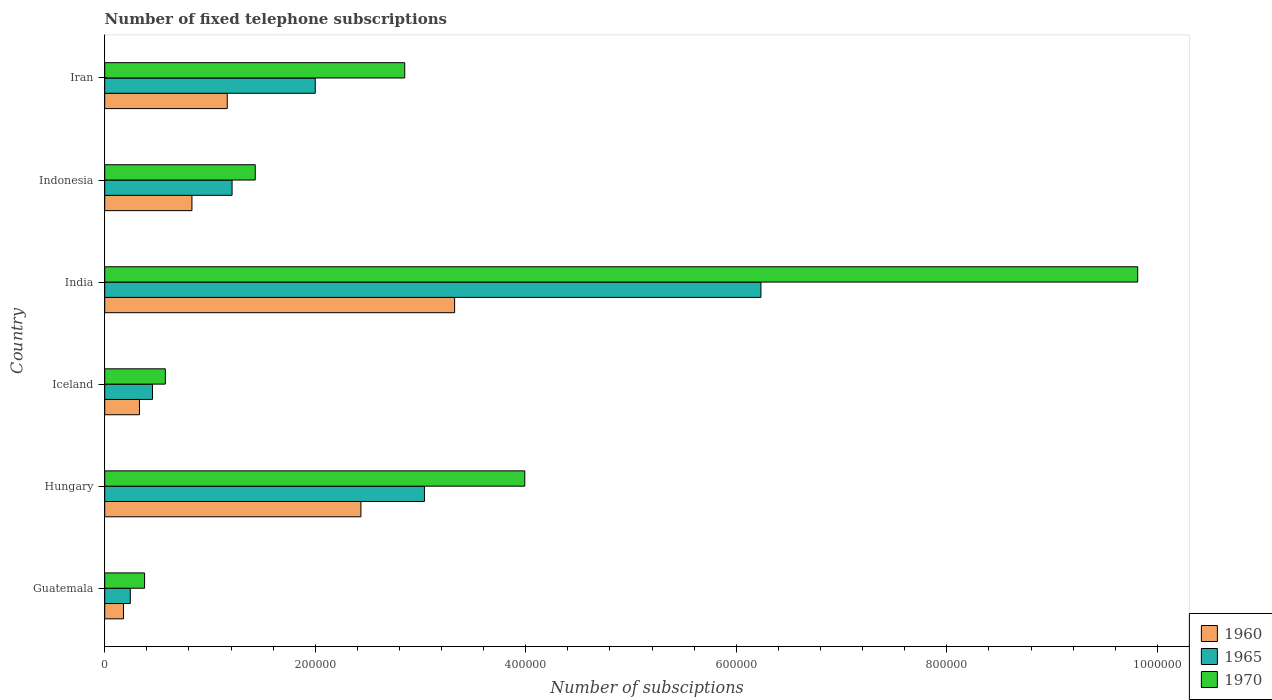How many bars are there on the 2nd tick from the top?
Provide a short and direct response. 3. How many bars are there on the 6th tick from the bottom?
Give a very brief answer. 3. What is the label of the 5th group of bars from the top?
Offer a terse response. Hungary. In how many cases, is the number of bars for a given country not equal to the number of legend labels?
Your answer should be compact. 0. What is the number of fixed telephone subscriptions in 1970 in Iceland?
Provide a succinct answer. 5.76e+04. Across all countries, what is the maximum number of fixed telephone subscriptions in 1965?
Provide a short and direct response. 6.23e+05. Across all countries, what is the minimum number of fixed telephone subscriptions in 1970?
Provide a succinct answer. 3.79e+04. In which country was the number of fixed telephone subscriptions in 1965 maximum?
Give a very brief answer. India. In which country was the number of fixed telephone subscriptions in 1965 minimum?
Provide a succinct answer. Guatemala. What is the total number of fixed telephone subscriptions in 1965 in the graph?
Your answer should be very brief. 1.32e+06. What is the difference between the number of fixed telephone subscriptions in 1960 in Guatemala and that in Hungary?
Your response must be concise. -2.26e+05. What is the difference between the number of fixed telephone subscriptions in 1965 in Iceland and the number of fixed telephone subscriptions in 1960 in Indonesia?
Your answer should be compact. -3.75e+04. What is the average number of fixed telephone subscriptions in 1960 per country?
Your answer should be compact. 1.38e+05. What is the difference between the number of fixed telephone subscriptions in 1970 and number of fixed telephone subscriptions in 1965 in Indonesia?
Your answer should be compact. 2.20e+04. What is the ratio of the number of fixed telephone subscriptions in 1960 in Hungary to that in Iran?
Offer a very short reply. 2.09. What is the difference between the highest and the second highest number of fixed telephone subscriptions in 1960?
Your answer should be compact. 8.90e+04. What is the difference between the highest and the lowest number of fixed telephone subscriptions in 1960?
Make the answer very short. 3.15e+05. In how many countries, is the number of fixed telephone subscriptions in 1965 greater than the average number of fixed telephone subscriptions in 1965 taken over all countries?
Offer a terse response. 2. What does the 1st bar from the bottom in Iran represents?
Your answer should be very brief. 1960. How many bars are there?
Ensure brevity in your answer.  18. Are all the bars in the graph horizontal?
Provide a succinct answer. Yes. Does the graph contain any zero values?
Give a very brief answer. No. Where does the legend appear in the graph?
Make the answer very short. Bottom right. What is the title of the graph?
Your answer should be very brief. Number of fixed telephone subscriptions. Does "1988" appear as one of the legend labels in the graph?
Offer a very short reply. No. What is the label or title of the X-axis?
Keep it short and to the point. Number of subsciptions. What is the label or title of the Y-axis?
Your answer should be very brief. Country. What is the Number of subsciptions in 1960 in Guatemala?
Keep it short and to the point. 1.78e+04. What is the Number of subsciptions of 1965 in Guatemala?
Your response must be concise. 2.43e+04. What is the Number of subsciptions in 1970 in Guatemala?
Provide a succinct answer. 3.79e+04. What is the Number of subsciptions in 1960 in Hungary?
Keep it short and to the point. 2.43e+05. What is the Number of subsciptions in 1965 in Hungary?
Offer a very short reply. 3.04e+05. What is the Number of subsciptions of 1970 in Hungary?
Your answer should be compact. 3.99e+05. What is the Number of subsciptions in 1960 in Iceland?
Keep it short and to the point. 3.30e+04. What is the Number of subsciptions of 1965 in Iceland?
Offer a terse response. 4.54e+04. What is the Number of subsciptions in 1970 in Iceland?
Make the answer very short. 5.76e+04. What is the Number of subsciptions in 1960 in India?
Your answer should be compact. 3.32e+05. What is the Number of subsciptions in 1965 in India?
Your response must be concise. 6.23e+05. What is the Number of subsciptions in 1970 in India?
Offer a terse response. 9.81e+05. What is the Number of subsciptions in 1960 in Indonesia?
Ensure brevity in your answer.  8.29e+04. What is the Number of subsciptions of 1965 in Indonesia?
Your answer should be very brief. 1.21e+05. What is the Number of subsciptions in 1970 in Indonesia?
Keep it short and to the point. 1.43e+05. What is the Number of subsciptions in 1960 in Iran?
Offer a very short reply. 1.16e+05. What is the Number of subsciptions in 1970 in Iran?
Ensure brevity in your answer.  2.85e+05. Across all countries, what is the maximum Number of subsciptions in 1960?
Your answer should be compact. 3.32e+05. Across all countries, what is the maximum Number of subsciptions in 1965?
Provide a succinct answer. 6.23e+05. Across all countries, what is the maximum Number of subsciptions in 1970?
Give a very brief answer. 9.81e+05. Across all countries, what is the minimum Number of subsciptions of 1960?
Your response must be concise. 1.78e+04. Across all countries, what is the minimum Number of subsciptions of 1965?
Your answer should be compact. 2.43e+04. Across all countries, what is the minimum Number of subsciptions of 1970?
Your answer should be compact. 3.79e+04. What is the total Number of subsciptions in 1960 in the graph?
Provide a short and direct response. 8.26e+05. What is the total Number of subsciptions of 1965 in the graph?
Offer a terse response. 1.32e+06. What is the total Number of subsciptions of 1970 in the graph?
Your response must be concise. 1.90e+06. What is the difference between the Number of subsciptions in 1960 in Guatemala and that in Hungary?
Your answer should be compact. -2.26e+05. What is the difference between the Number of subsciptions in 1965 in Guatemala and that in Hungary?
Ensure brevity in your answer.  -2.79e+05. What is the difference between the Number of subsciptions in 1970 in Guatemala and that in Hungary?
Provide a succinct answer. -3.61e+05. What is the difference between the Number of subsciptions in 1960 in Guatemala and that in Iceland?
Your response must be concise. -1.52e+04. What is the difference between the Number of subsciptions in 1965 in Guatemala and that in Iceland?
Provide a short and direct response. -2.11e+04. What is the difference between the Number of subsciptions in 1970 in Guatemala and that in Iceland?
Offer a terse response. -1.97e+04. What is the difference between the Number of subsciptions of 1960 in Guatemala and that in India?
Give a very brief answer. -3.15e+05. What is the difference between the Number of subsciptions of 1965 in Guatemala and that in India?
Your response must be concise. -5.99e+05. What is the difference between the Number of subsciptions in 1970 in Guatemala and that in India?
Offer a very short reply. -9.43e+05. What is the difference between the Number of subsciptions in 1960 in Guatemala and that in Indonesia?
Your response must be concise. -6.50e+04. What is the difference between the Number of subsciptions of 1965 in Guatemala and that in Indonesia?
Offer a terse response. -9.67e+04. What is the difference between the Number of subsciptions in 1970 in Guatemala and that in Indonesia?
Make the answer very short. -1.05e+05. What is the difference between the Number of subsciptions of 1960 in Guatemala and that in Iran?
Offer a terse response. -9.86e+04. What is the difference between the Number of subsciptions in 1965 in Guatemala and that in Iran?
Provide a short and direct response. -1.76e+05. What is the difference between the Number of subsciptions of 1970 in Guatemala and that in Iran?
Your answer should be compact. -2.47e+05. What is the difference between the Number of subsciptions in 1960 in Hungary and that in Iceland?
Give a very brief answer. 2.10e+05. What is the difference between the Number of subsciptions in 1965 in Hungary and that in Iceland?
Keep it short and to the point. 2.58e+05. What is the difference between the Number of subsciptions in 1970 in Hungary and that in Iceland?
Give a very brief answer. 3.41e+05. What is the difference between the Number of subsciptions of 1960 in Hungary and that in India?
Ensure brevity in your answer.  -8.90e+04. What is the difference between the Number of subsciptions in 1965 in Hungary and that in India?
Ensure brevity in your answer.  -3.20e+05. What is the difference between the Number of subsciptions in 1970 in Hungary and that in India?
Make the answer very short. -5.82e+05. What is the difference between the Number of subsciptions in 1960 in Hungary and that in Indonesia?
Keep it short and to the point. 1.61e+05. What is the difference between the Number of subsciptions in 1965 in Hungary and that in Indonesia?
Your response must be concise. 1.83e+05. What is the difference between the Number of subsciptions in 1970 in Hungary and that in Indonesia?
Keep it short and to the point. 2.56e+05. What is the difference between the Number of subsciptions of 1960 in Hungary and that in Iran?
Provide a succinct answer. 1.27e+05. What is the difference between the Number of subsciptions in 1965 in Hungary and that in Iran?
Provide a succinct answer. 1.04e+05. What is the difference between the Number of subsciptions in 1970 in Hungary and that in Iran?
Make the answer very short. 1.14e+05. What is the difference between the Number of subsciptions in 1960 in Iceland and that in India?
Provide a succinct answer. -2.99e+05. What is the difference between the Number of subsciptions in 1965 in Iceland and that in India?
Your answer should be compact. -5.78e+05. What is the difference between the Number of subsciptions in 1970 in Iceland and that in India?
Provide a short and direct response. -9.24e+05. What is the difference between the Number of subsciptions of 1960 in Iceland and that in Indonesia?
Provide a succinct answer. -4.99e+04. What is the difference between the Number of subsciptions of 1965 in Iceland and that in Indonesia?
Provide a succinct answer. -7.56e+04. What is the difference between the Number of subsciptions in 1970 in Iceland and that in Indonesia?
Ensure brevity in your answer.  -8.54e+04. What is the difference between the Number of subsciptions in 1960 in Iceland and that in Iran?
Your answer should be very brief. -8.34e+04. What is the difference between the Number of subsciptions in 1965 in Iceland and that in Iran?
Your answer should be very brief. -1.55e+05. What is the difference between the Number of subsciptions of 1970 in Iceland and that in Iran?
Give a very brief answer. -2.27e+05. What is the difference between the Number of subsciptions of 1960 in India and that in Indonesia?
Give a very brief answer. 2.50e+05. What is the difference between the Number of subsciptions of 1965 in India and that in Indonesia?
Offer a terse response. 5.02e+05. What is the difference between the Number of subsciptions of 1970 in India and that in Indonesia?
Your response must be concise. 8.38e+05. What is the difference between the Number of subsciptions of 1960 in India and that in Iran?
Offer a very short reply. 2.16e+05. What is the difference between the Number of subsciptions in 1965 in India and that in Iran?
Your answer should be compact. 4.23e+05. What is the difference between the Number of subsciptions of 1970 in India and that in Iran?
Your response must be concise. 6.96e+05. What is the difference between the Number of subsciptions of 1960 in Indonesia and that in Iran?
Provide a succinct answer. -3.36e+04. What is the difference between the Number of subsciptions in 1965 in Indonesia and that in Iran?
Ensure brevity in your answer.  -7.90e+04. What is the difference between the Number of subsciptions of 1970 in Indonesia and that in Iran?
Make the answer very short. -1.42e+05. What is the difference between the Number of subsciptions of 1960 in Guatemala and the Number of subsciptions of 1965 in Hungary?
Provide a short and direct response. -2.86e+05. What is the difference between the Number of subsciptions in 1960 in Guatemala and the Number of subsciptions in 1970 in Hungary?
Your response must be concise. -3.81e+05. What is the difference between the Number of subsciptions in 1965 in Guatemala and the Number of subsciptions in 1970 in Hungary?
Your response must be concise. -3.75e+05. What is the difference between the Number of subsciptions in 1960 in Guatemala and the Number of subsciptions in 1965 in Iceland?
Make the answer very short. -2.75e+04. What is the difference between the Number of subsciptions of 1960 in Guatemala and the Number of subsciptions of 1970 in Iceland?
Offer a terse response. -3.98e+04. What is the difference between the Number of subsciptions of 1965 in Guatemala and the Number of subsciptions of 1970 in Iceland?
Make the answer very short. -3.33e+04. What is the difference between the Number of subsciptions of 1960 in Guatemala and the Number of subsciptions of 1965 in India?
Make the answer very short. -6.06e+05. What is the difference between the Number of subsciptions of 1960 in Guatemala and the Number of subsciptions of 1970 in India?
Ensure brevity in your answer.  -9.64e+05. What is the difference between the Number of subsciptions of 1965 in Guatemala and the Number of subsciptions of 1970 in India?
Offer a terse response. -9.57e+05. What is the difference between the Number of subsciptions in 1960 in Guatemala and the Number of subsciptions in 1965 in Indonesia?
Offer a terse response. -1.03e+05. What is the difference between the Number of subsciptions in 1960 in Guatemala and the Number of subsciptions in 1970 in Indonesia?
Make the answer very short. -1.25e+05. What is the difference between the Number of subsciptions in 1965 in Guatemala and the Number of subsciptions in 1970 in Indonesia?
Make the answer very short. -1.19e+05. What is the difference between the Number of subsciptions in 1960 in Guatemala and the Number of subsciptions in 1965 in Iran?
Provide a short and direct response. -1.82e+05. What is the difference between the Number of subsciptions in 1960 in Guatemala and the Number of subsciptions in 1970 in Iran?
Offer a very short reply. -2.67e+05. What is the difference between the Number of subsciptions of 1965 in Guatemala and the Number of subsciptions of 1970 in Iran?
Your response must be concise. -2.61e+05. What is the difference between the Number of subsciptions in 1960 in Hungary and the Number of subsciptions in 1965 in Iceland?
Your response must be concise. 1.98e+05. What is the difference between the Number of subsciptions in 1960 in Hungary and the Number of subsciptions in 1970 in Iceland?
Offer a very short reply. 1.86e+05. What is the difference between the Number of subsciptions in 1965 in Hungary and the Number of subsciptions in 1970 in Iceland?
Your answer should be very brief. 2.46e+05. What is the difference between the Number of subsciptions of 1960 in Hungary and the Number of subsciptions of 1965 in India?
Ensure brevity in your answer.  -3.80e+05. What is the difference between the Number of subsciptions of 1960 in Hungary and the Number of subsciptions of 1970 in India?
Offer a terse response. -7.38e+05. What is the difference between the Number of subsciptions in 1965 in Hungary and the Number of subsciptions in 1970 in India?
Make the answer very short. -6.78e+05. What is the difference between the Number of subsciptions of 1960 in Hungary and the Number of subsciptions of 1965 in Indonesia?
Make the answer very short. 1.22e+05. What is the difference between the Number of subsciptions of 1960 in Hungary and the Number of subsciptions of 1970 in Indonesia?
Offer a very short reply. 1.00e+05. What is the difference between the Number of subsciptions in 1965 in Hungary and the Number of subsciptions in 1970 in Indonesia?
Make the answer very short. 1.61e+05. What is the difference between the Number of subsciptions of 1960 in Hungary and the Number of subsciptions of 1965 in Iran?
Your response must be concise. 4.34e+04. What is the difference between the Number of subsciptions of 1960 in Hungary and the Number of subsciptions of 1970 in Iran?
Make the answer very short. -4.16e+04. What is the difference between the Number of subsciptions of 1965 in Hungary and the Number of subsciptions of 1970 in Iran?
Ensure brevity in your answer.  1.88e+04. What is the difference between the Number of subsciptions in 1960 in Iceland and the Number of subsciptions in 1965 in India?
Your answer should be compact. -5.90e+05. What is the difference between the Number of subsciptions of 1960 in Iceland and the Number of subsciptions of 1970 in India?
Keep it short and to the point. -9.48e+05. What is the difference between the Number of subsciptions of 1965 in Iceland and the Number of subsciptions of 1970 in India?
Offer a very short reply. -9.36e+05. What is the difference between the Number of subsciptions of 1960 in Iceland and the Number of subsciptions of 1965 in Indonesia?
Provide a short and direct response. -8.80e+04. What is the difference between the Number of subsciptions in 1960 in Iceland and the Number of subsciptions in 1970 in Indonesia?
Ensure brevity in your answer.  -1.10e+05. What is the difference between the Number of subsciptions in 1965 in Iceland and the Number of subsciptions in 1970 in Indonesia?
Provide a succinct answer. -9.76e+04. What is the difference between the Number of subsciptions of 1960 in Iceland and the Number of subsciptions of 1965 in Iran?
Offer a very short reply. -1.67e+05. What is the difference between the Number of subsciptions in 1960 in Iceland and the Number of subsciptions in 1970 in Iran?
Your answer should be compact. -2.52e+05. What is the difference between the Number of subsciptions of 1965 in Iceland and the Number of subsciptions of 1970 in Iran?
Ensure brevity in your answer.  -2.40e+05. What is the difference between the Number of subsciptions of 1960 in India and the Number of subsciptions of 1965 in Indonesia?
Make the answer very short. 2.11e+05. What is the difference between the Number of subsciptions in 1960 in India and the Number of subsciptions in 1970 in Indonesia?
Offer a very short reply. 1.89e+05. What is the difference between the Number of subsciptions in 1965 in India and the Number of subsciptions in 1970 in Indonesia?
Your answer should be compact. 4.80e+05. What is the difference between the Number of subsciptions of 1960 in India and the Number of subsciptions of 1965 in Iran?
Ensure brevity in your answer.  1.32e+05. What is the difference between the Number of subsciptions in 1960 in India and the Number of subsciptions in 1970 in Iran?
Your response must be concise. 4.74e+04. What is the difference between the Number of subsciptions of 1965 in India and the Number of subsciptions of 1970 in Iran?
Ensure brevity in your answer.  3.38e+05. What is the difference between the Number of subsciptions in 1960 in Indonesia and the Number of subsciptions in 1965 in Iran?
Provide a short and direct response. -1.17e+05. What is the difference between the Number of subsciptions of 1960 in Indonesia and the Number of subsciptions of 1970 in Iran?
Provide a succinct answer. -2.02e+05. What is the difference between the Number of subsciptions in 1965 in Indonesia and the Number of subsciptions in 1970 in Iran?
Keep it short and to the point. -1.64e+05. What is the average Number of subsciptions of 1960 per country?
Make the answer very short. 1.38e+05. What is the average Number of subsciptions in 1965 per country?
Your response must be concise. 2.20e+05. What is the average Number of subsciptions in 1970 per country?
Ensure brevity in your answer.  3.17e+05. What is the difference between the Number of subsciptions in 1960 and Number of subsciptions in 1965 in Guatemala?
Make the answer very short. -6485. What is the difference between the Number of subsciptions in 1960 and Number of subsciptions in 1970 in Guatemala?
Your answer should be very brief. -2.00e+04. What is the difference between the Number of subsciptions in 1965 and Number of subsciptions in 1970 in Guatemala?
Ensure brevity in your answer.  -1.36e+04. What is the difference between the Number of subsciptions of 1960 and Number of subsciptions of 1965 in Hungary?
Ensure brevity in your answer.  -6.04e+04. What is the difference between the Number of subsciptions of 1960 and Number of subsciptions of 1970 in Hungary?
Make the answer very short. -1.56e+05. What is the difference between the Number of subsciptions of 1965 and Number of subsciptions of 1970 in Hungary?
Your answer should be compact. -9.53e+04. What is the difference between the Number of subsciptions in 1960 and Number of subsciptions in 1965 in Iceland?
Provide a succinct answer. -1.24e+04. What is the difference between the Number of subsciptions in 1960 and Number of subsciptions in 1970 in Iceland?
Your response must be concise. -2.46e+04. What is the difference between the Number of subsciptions of 1965 and Number of subsciptions of 1970 in Iceland?
Your response must be concise. -1.22e+04. What is the difference between the Number of subsciptions in 1960 and Number of subsciptions in 1965 in India?
Your response must be concise. -2.91e+05. What is the difference between the Number of subsciptions in 1960 and Number of subsciptions in 1970 in India?
Ensure brevity in your answer.  -6.49e+05. What is the difference between the Number of subsciptions of 1965 and Number of subsciptions of 1970 in India?
Make the answer very short. -3.58e+05. What is the difference between the Number of subsciptions of 1960 and Number of subsciptions of 1965 in Indonesia?
Your answer should be compact. -3.81e+04. What is the difference between the Number of subsciptions of 1960 and Number of subsciptions of 1970 in Indonesia?
Your answer should be very brief. -6.01e+04. What is the difference between the Number of subsciptions in 1965 and Number of subsciptions in 1970 in Indonesia?
Provide a succinct answer. -2.20e+04. What is the difference between the Number of subsciptions in 1960 and Number of subsciptions in 1965 in Iran?
Offer a terse response. -8.36e+04. What is the difference between the Number of subsciptions of 1960 and Number of subsciptions of 1970 in Iran?
Offer a terse response. -1.69e+05. What is the difference between the Number of subsciptions in 1965 and Number of subsciptions in 1970 in Iran?
Your answer should be compact. -8.50e+04. What is the ratio of the Number of subsciptions in 1960 in Guatemala to that in Hungary?
Give a very brief answer. 0.07. What is the ratio of the Number of subsciptions of 1965 in Guatemala to that in Hungary?
Provide a short and direct response. 0.08. What is the ratio of the Number of subsciptions in 1970 in Guatemala to that in Hungary?
Make the answer very short. 0.09. What is the ratio of the Number of subsciptions of 1960 in Guatemala to that in Iceland?
Keep it short and to the point. 0.54. What is the ratio of the Number of subsciptions of 1965 in Guatemala to that in Iceland?
Offer a terse response. 0.54. What is the ratio of the Number of subsciptions of 1970 in Guatemala to that in Iceland?
Your answer should be very brief. 0.66. What is the ratio of the Number of subsciptions of 1960 in Guatemala to that in India?
Your response must be concise. 0.05. What is the ratio of the Number of subsciptions of 1965 in Guatemala to that in India?
Keep it short and to the point. 0.04. What is the ratio of the Number of subsciptions of 1970 in Guatemala to that in India?
Your response must be concise. 0.04. What is the ratio of the Number of subsciptions of 1960 in Guatemala to that in Indonesia?
Your answer should be very brief. 0.22. What is the ratio of the Number of subsciptions of 1965 in Guatemala to that in Indonesia?
Your answer should be compact. 0.2. What is the ratio of the Number of subsciptions of 1970 in Guatemala to that in Indonesia?
Make the answer very short. 0.26. What is the ratio of the Number of subsciptions of 1960 in Guatemala to that in Iran?
Keep it short and to the point. 0.15. What is the ratio of the Number of subsciptions in 1965 in Guatemala to that in Iran?
Your answer should be compact. 0.12. What is the ratio of the Number of subsciptions of 1970 in Guatemala to that in Iran?
Make the answer very short. 0.13. What is the ratio of the Number of subsciptions of 1960 in Hungary to that in Iceland?
Offer a very short reply. 7.38. What is the ratio of the Number of subsciptions in 1965 in Hungary to that in Iceland?
Keep it short and to the point. 6.7. What is the ratio of the Number of subsciptions in 1970 in Hungary to that in Iceland?
Provide a succinct answer. 6.93. What is the ratio of the Number of subsciptions in 1960 in Hungary to that in India?
Your answer should be compact. 0.73. What is the ratio of the Number of subsciptions of 1965 in Hungary to that in India?
Keep it short and to the point. 0.49. What is the ratio of the Number of subsciptions in 1970 in Hungary to that in India?
Your answer should be very brief. 0.41. What is the ratio of the Number of subsciptions in 1960 in Hungary to that in Indonesia?
Your answer should be very brief. 2.94. What is the ratio of the Number of subsciptions in 1965 in Hungary to that in Indonesia?
Ensure brevity in your answer.  2.51. What is the ratio of the Number of subsciptions in 1970 in Hungary to that in Indonesia?
Your response must be concise. 2.79. What is the ratio of the Number of subsciptions of 1960 in Hungary to that in Iran?
Your response must be concise. 2.09. What is the ratio of the Number of subsciptions of 1965 in Hungary to that in Iran?
Provide a succinct answer. 1.52. What is the ratio of the Number of subsciptions of 1970 in Hungary to that in Iran?
Offer a very short reply. 1.4. What is the ratio of the Number of subsciptions in 1960 in Iceland to that in India?
Provide a succinct answer. 0.1. What is the ratio of the Number of subsciptions in 1965 in Iceland to that in India?
Your answer should be compact. 0.07. What is the ratio of the Number of subsciptions of 1970 in Iceland to that in India?
Provide a short and direct response. 0.06. What is the ratio of the Number of subsciptions in 1960 in Iceland to that in Indonesia?
Offer a terse response. 0.4. What is the ratio of the Number of subsciptions in 1965 in Iceland to that in Indonesia?
Your answer should be very brief. 0.37. What is the ratio of the Number of subsciptions of 1970 in Iceland to that in Indonesia?
Your answer should be very brief. 0.4. What is the ratio of the Number of subsciptions of 1960 in Iceland to that in Iran?
Your answer should be compact. 0.28. What is the ratio of the Number of subsciptions of 1965 in Iceland to that in Iran?
Make the answer very short. 0.23. What is the ratio of the Number of subsciptions in 1970 in Iceland to that in Iran?
Give a very brief answer. 0.2. What is the ratio of the Number of subsciptions in 1960 in India to that in Indonesia?
Give a very brief answer. 4.01. What is the ratio of the Number of subsciptions in 1965 in India to that in Indonesia?
Your answer should be very brief. 5.15. What is the ratio of the Number of subsciptions of 1970 in India to that in Indonesia?
Provide a succinct answer. 6.86. What is the ratio of the Number of subsciptions in 1960 in India to that in Iran?
Offer a terse response. 2.86. What is the ratio of the Number of subsciptions in 1965 in India to that in Iran?
Provide a succinct answer. 3.12. What is the ratio of the Number of subsciptions of 1970 in India to that in Iran?
Your answer should be compact. 3.44. What is the ratio of the Number of subsciptions in 1960 in Indonesia to that in Iran?
Provide a succinct answer. 0.71. What is the ratio of the Number of subsciptions of 1965 in Indonesia to that in Iran?
Offer a terse response. 0.6. What is the ratio of the Number of subsciptions in 1970 in Indonesia to that in Iran?
Provide a succinct answer. 0.5. What is the difference between the highest and the second highest Number of subsciptions of 1960?
Your response must be concise. 8.90e+04. What is the difference between the highest and the second highest Number of subsciptions in 1965?
Give a very brief answer. 3.20e+05. What is the difference between the highest and the second highest Number of subsciptions of 1970?
Provide a succinct answer. 5.82e+05. What is the difference between the highest and the lowest Number of subsciptions of 1960?
Make the answer very short. 3.15e+05. What is the difference between the highest and the lowest Number of subsciptions of 1965?
Offer a terse response. 5.99e+05. What is the difference between the highest and the lowest Number of subsciptions in 1970?
Your answer should be compact. 9.43e+05. 